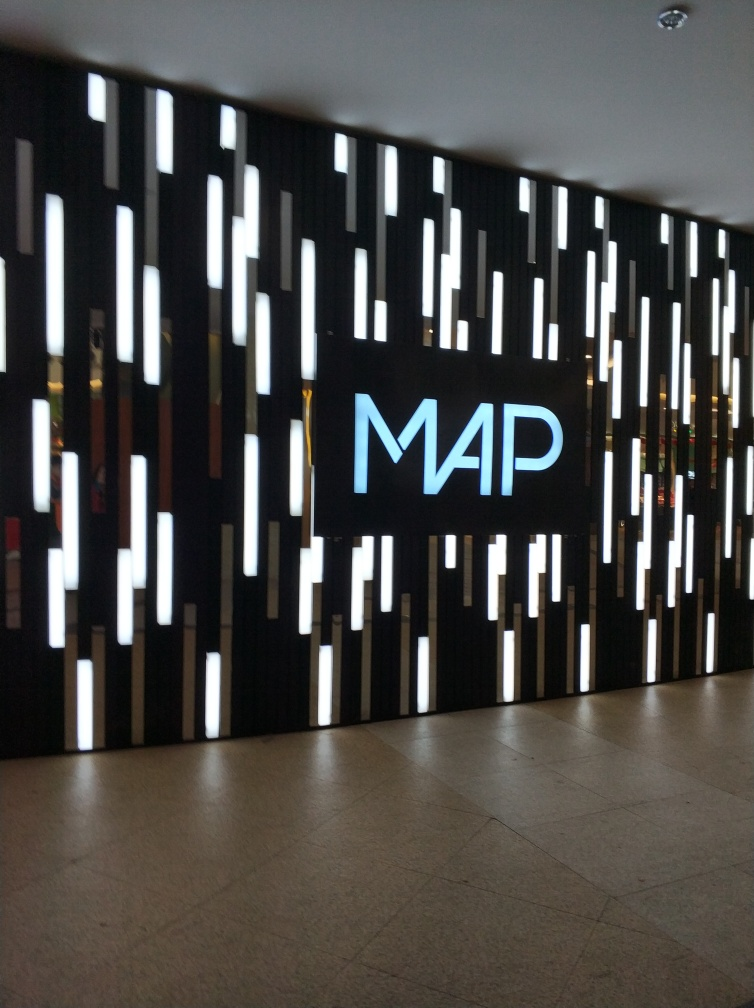Does the main subject, the wall, retain most of its texture details? Yes, the main subject of the image, which is the uniquely designed wall, appears to retain most of its texture details. The wall features a creative pattern with illuminated lines that vary in brightness and size, providing a visually interesting and textured appearance. 